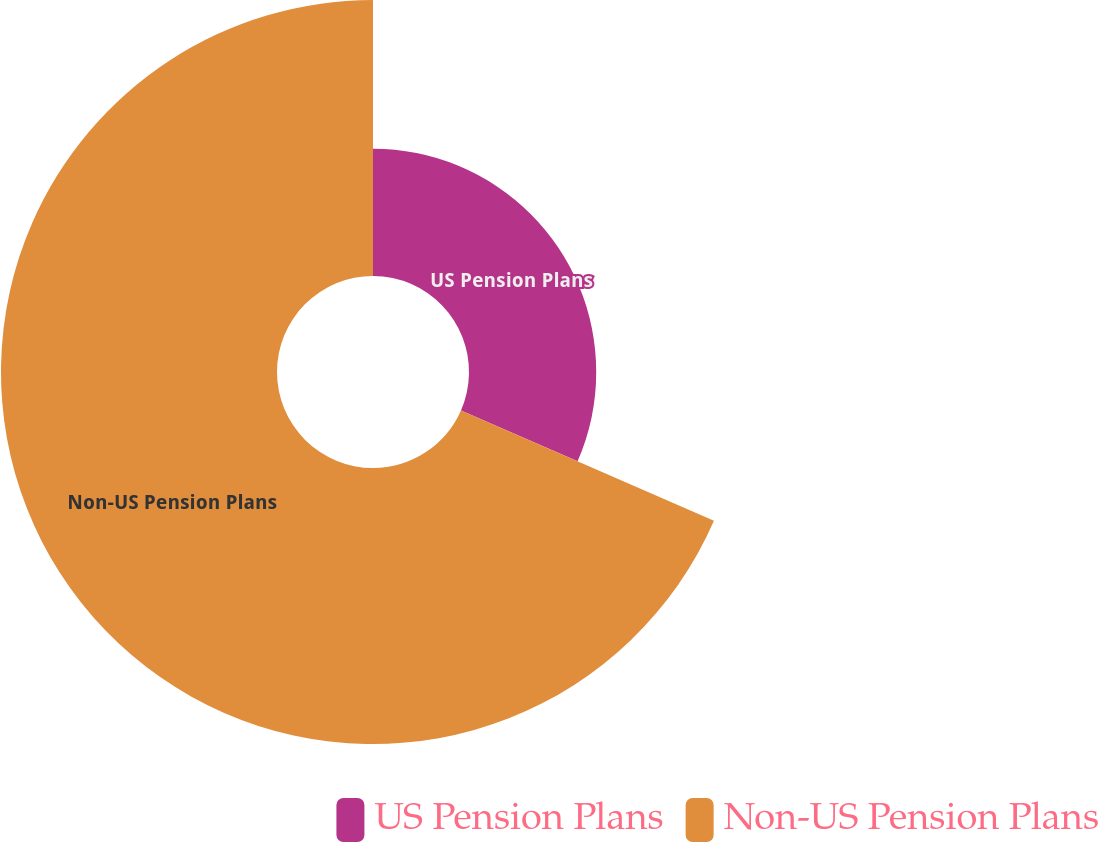Convert chart. <chart><loc_0><loc_0><loc_500><loc_500><pie_chart><fcel>US Pension Plans<fcel>Non-US Pension Plans<nl><fcel>31.55%<fcel>68.45%<nl></chart> 